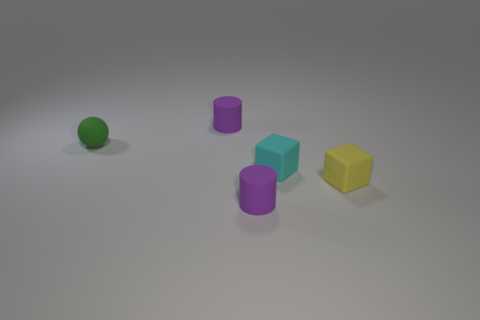Add 3 small brown metallic blocks. How many objects exist? 8 Subtract all blocks. How many objects are left? 3 Subtract 1 cylinders. How many cylinders are left? 1 Subtract all blue cubes. Subtract all cyan cylinders. How many cubes are left? 2 Add 1 rubber blocks. How many rubber blocks are left? 3 Add 3 tiny rubber blocks. How many tiny rubber blocks exist? 5 Subtract 1 cyan cubes. How many objects are left? 4 Subtract all small blue cubes. Subtract all balls. How many objects are left? 4 